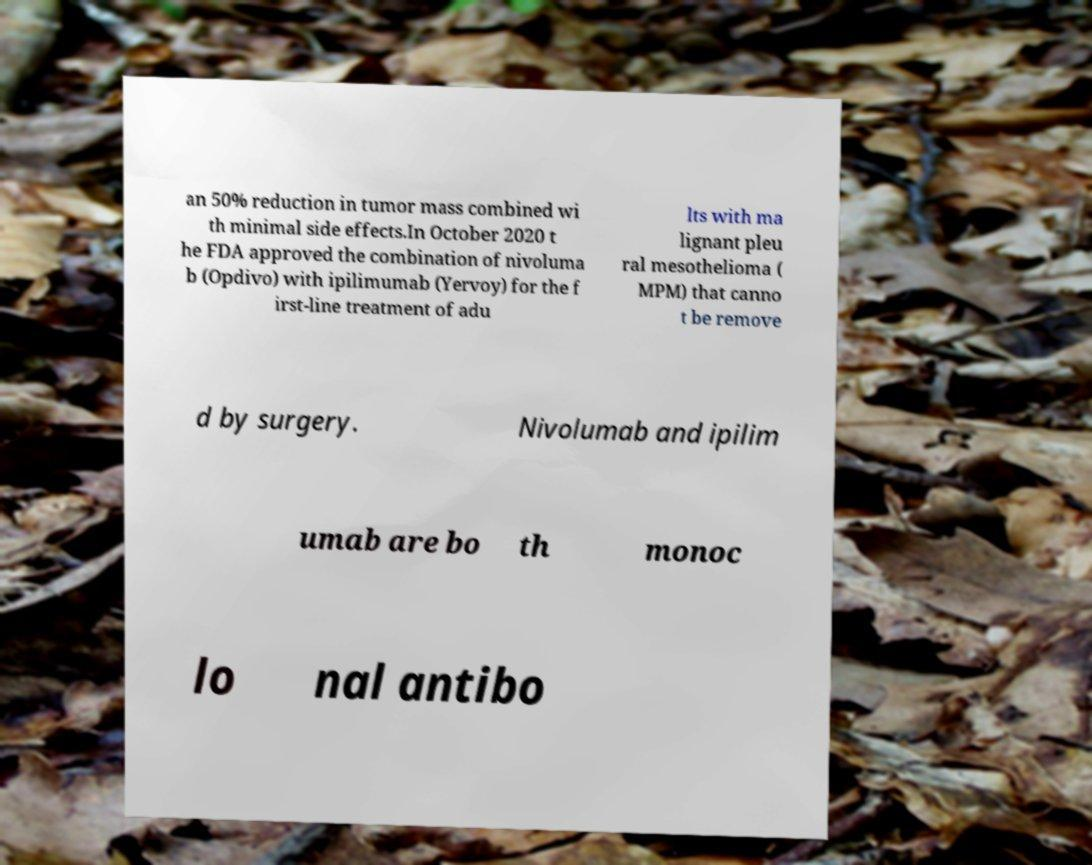For documentation purposes, I need the text within this image transcribed. Could you provide that? an 50% reduction in tumor mass combined wi th minimal side effects.In October 2020 t he FDA approved the combination of nivoluma b (Opdivo) with ipilimumab (Yervoy) for the f irst-line treatment of adu lts with ma lignant pleu ral mesothelioma ( MPM) that canno t be remove d by surgery. Nivolumab and ipilim umab are bo th monoc lo nal antibo 